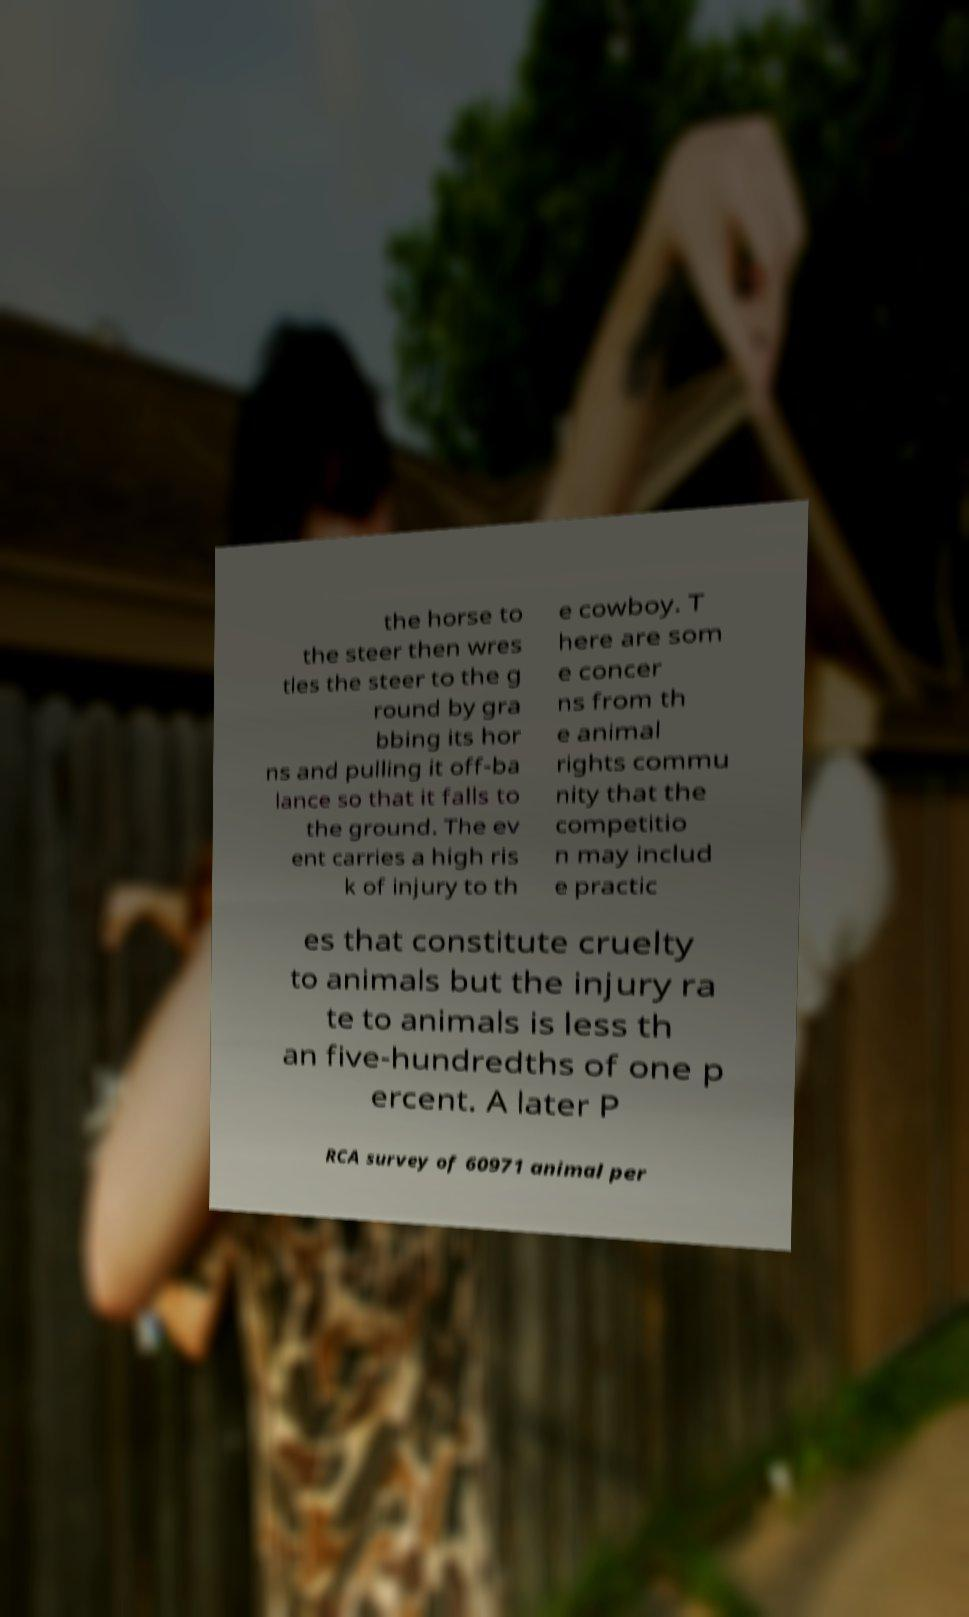There's text embedded in this image that I need extracted. Can you transcribe it verbatim? the horse to the steer then wres tles the steer to the g round by gra bbing its hor ns and pulling it off-ba lance so that it falls to the ground. The ev ent carries a high ris k of injury to th e cowboy. T here are som e concer ns from th e animal rights commu nity that the competitio n may includ e practic es that constitute cruelty to animals but the injury ra te to animals is less th an five-hundredths of one p ercent. A later P RCA survey of 60971 animal per 